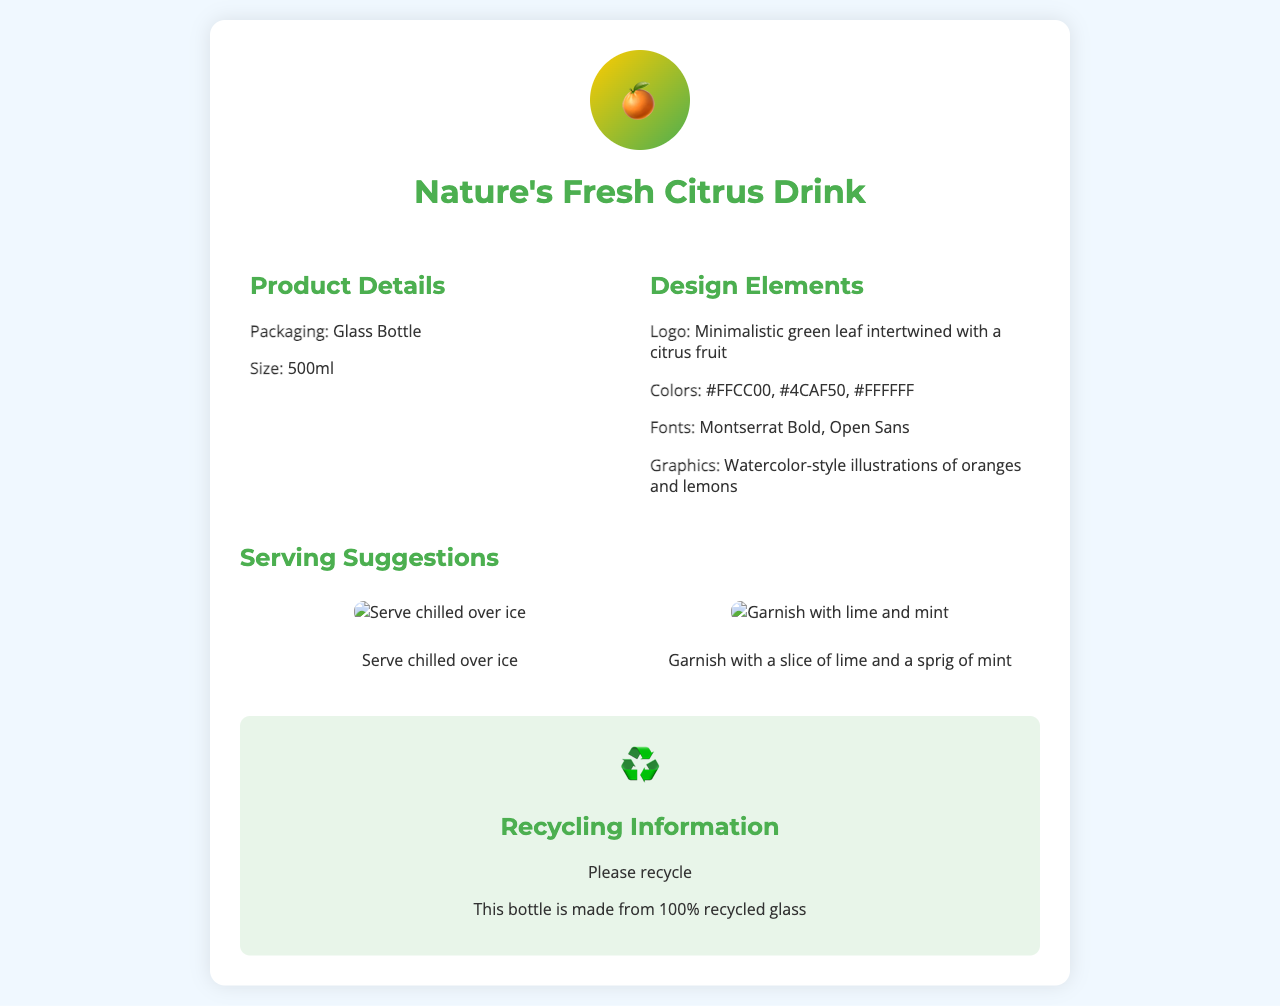What is the packaging type? The packaging type is specified prominently in the product details section of the document.
Answer: Glass Bottle What is the size of the beverage? The document states the size of the beverage directly under the packaging type.
Answer: 500ml What design color is listed first? The design colors are mentioned in order, and the first one is highlighted in the design elements section.
Answer: #FFCC00 What is the main graphic style used in the design? The document refers to the style of the illustrations used in the design elements section.
Answer: Watercolor-style How should the beverage be served? The serving suggestions provide direct instructions and examples for serving the beverage.
Answer: Serve chilled over ice What symbol represents recycling in the document? The document includes a visual cue for recycling, which can be identified in the recycling information section.
Answer: ♻️ What is the bottle made from? The recycling information specifically outlines the material used for the bottle.
Answer: 100% recycled glass Which font is used for the product title? The document lists the fonts used for various elements, including the product title.
Answer: Montserrat Bold What garnish is suggested for the drink? The serving suggestions provide specific garnishing recommendations for the beverage.
Answer: Lime and mint 